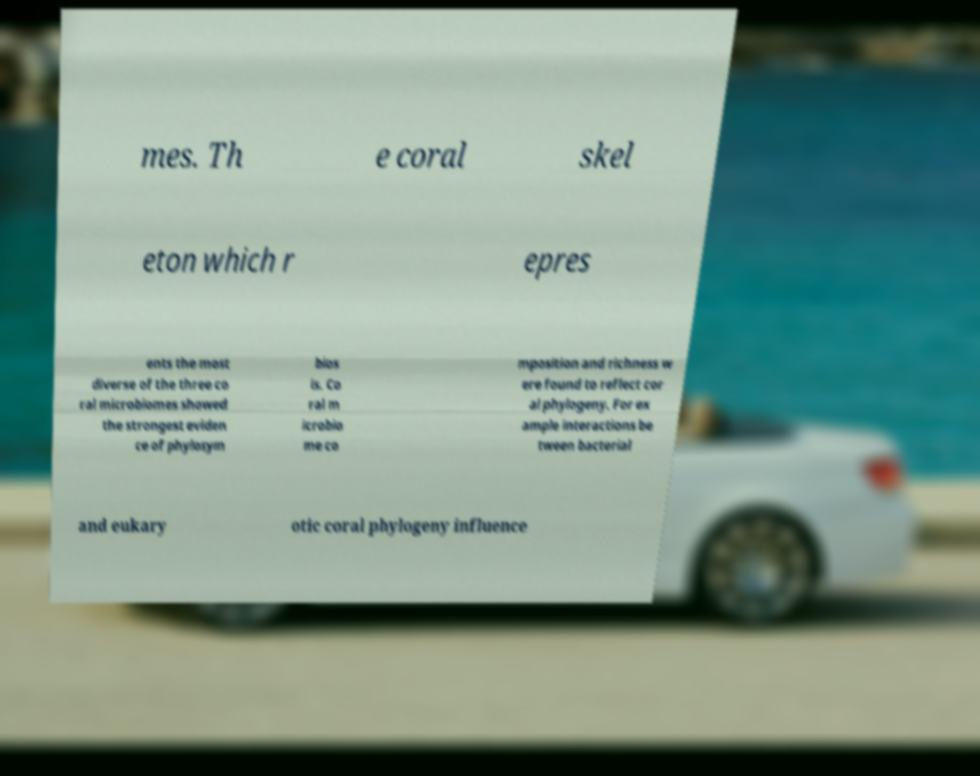Please read and relay the text visible in this image. What does it say? mes. Th e coral skel eton which r epres ents the most diverse of the three co ral microbiomes showed the strongest eviden ce of phylosym bios is. Co ral m icrobio me co mposition and richness w ere found to reflect cor al phylogeny. For ex ample interactions be tween bacterial and eukary otic coral phylogeny influence 